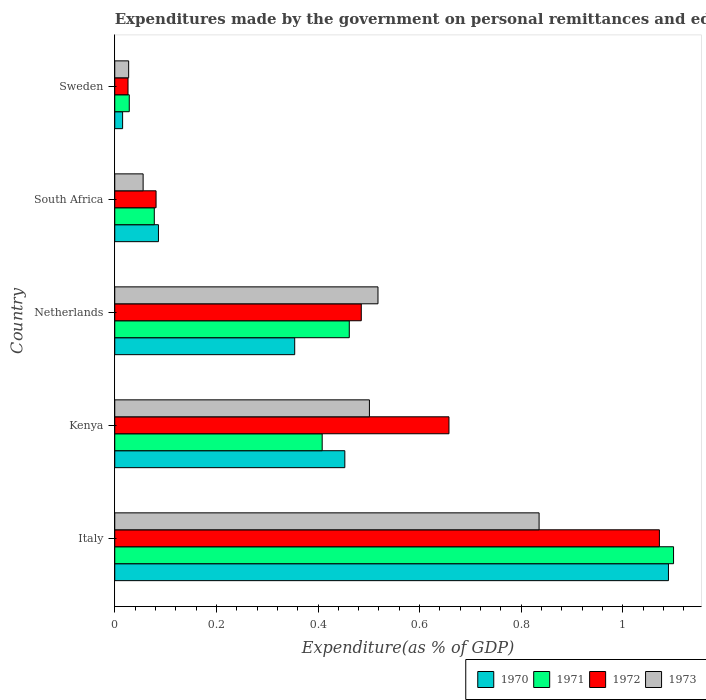How many different coloured bars are there?
Offer a terse response. 4. Are the number of bars per tick equal to the number of legend labels?
Provide a succinct answer. Yes. In how many cases, is the number of bars for a given country not equal to the number of legend labels?
Your answer should be very brief. 0. What is the expenditures made by the government on personal remittances and education in 1971 in South Africa?
Offer a terse response. 0.08. Across all countries, what is the maximum expenditures made by the government on personal remittances and education in 1970?
Offer a terse response. 1.09. Across all countries, what is the minimum expenditures made by the government on personal remittances and education in 1972?
Your response must be concise. 0.03. In which country was the expenditures made by the government on personal remittances and education in 1972 maximum?
Your response must be concise. Italy. In which country was the expenditures made by the government on personal remittances and education in 1970 minimum?
Keep it short and to the point. Sweden. What is the total expenditures made by the government on personal remittances and education in 1972 in the graph?
Offer a very short reply. 2.32. What is the difference between the expenditures made by the government on personal remittances and education in 1970 in Kenya and that in Sweden?
Offer a terse response. 0.44. What is the difference between the expenditures made by the government on personal remittances and education in 1971 in Kenya and the expenditures made by the government on personal remittances and education in 1972 in Netherlands?
Your answer should be compact. -0.08. What is the average expenditures made by the government on personal remittances and education in 1971 per country?
Provide a short and direct response. 0.42. What is the difference between the expenditures made by the government on personal remittances and education in 1972 and expenditures made by the government on personal remittances and education in 1973 in Italy?
Your response must be concise. 0.24. In how many countries, is the expenditures made by the government on personal remittances and education in 1972 greater than 0.56 %?
Offer a very short reply. 2. What is the ratio of the expenditures made by the government on personal remittances and education in 1971 in Kenya to that in Sweden?
Give a very brief answer. 14.29. Is the difference between the expenditures made by the government on personal remittances and education in 1972 in South Africa and Sweden greater than the difference between the expenditures made by the government on personal remittances and education in 1973 in South Africa and Sweden?
Offer a very short reply. Yes. What is the difference between the highest and the second highest expenditures made by the government on personal remittances and education in 1972?
Offer a very short reply. 0.41. What is the difference between the highest and the lowest expenditures made by the government on personal remittances and education in 1972?
Provide a short and direct response. 1.05. What does the 4th bar from the top in Italy represents?
Keep it short and to the point. 1970. Is it the case that in every country, the sum of the expenditures made by the government on personal remittances and education in 1971 and expenditures made by the government on personal remittances and education in 1973 is greater than the expenditures made by the government on personal remittances and education in 1972?
Your answer should be compact. Yes. Are all the bars in the graph horizontal?
Provide a short and direct response. Yes. Where does the legend appear in the graph?
Give a very brief answer. Bottom right. How are the legend labels stacked?
Your response must be concise. Horizontal. What is the title of the graph?
Give a very brief answer. Expenditures made by the government on personal remittances and education. Does "1975" appear as one of the legend labels in the graph?
Your answer should be compact. No. What is the label or title of the X-axis?
Your answer should be very brief. Expenditure(as % of GDP). What is the Expenditure(as % of GDP) in 1970 in Italy?
Give a very brief answer. 1.09. What is the Expenditure(as % of GDP) of 1971 in Italy?
Ensure brevity in your answer.  1.1. What is the Expenditure(as % of GDP) in 1972 in Italy?
Offer a very short reply. 1.07. What is the Expenditure(as % of GDP) in 1973 in Italy?
Offer a terse response. 0.84. What is the Expenditure(as % of GDP) of 1970 in Kenya?
Your answer should be compact. 0.45. What is the Expenditure(as % of GDP) in 1971 in Kenya?
Your response must be concise. 0.41. What is the Expenditure(as % of GDP) of 1972 in Kenya?
Offer a very short reply. 0.66. What is the Expenditure(as % of GDP) in 1973 in Kenya?
Your answer should be very brief. 0.5. What is the Expenditure(as % of GDP) in 1970 in Netherlands?
Your answer should be compact. 0.35. What is the Expenditure(as % of GDP) of 1971 in Netherlands?
Provide a succinct answer. 0.46. What is the Expenditure(as % of GDP) in 1972 in Netherlands?
Ensure brevity in your answer.  0.49. What is the Expenditure(as % of GDP) in 1973 in Netherlands?
Offer a terse response. 0.52. What is the Expenditure(as % of GDP) in 1970 in South Africa?
Give a very brief answer. 0.09. What is the Expenditure(as % of GDP) in 1971 in South Africa?
Your answer should be very brief. 0.08. What is the Expenditure(as % of GDP) of 1972 in South Africa?
Make the answer very short. 0.08. What is the Expenditure(as % of GDP) of 1973 in South Africa?
Offer a terse response. 0.06. What is the Expenditure(as % of GDP) of 1970 in Sweden?
Ensure brevity in your answer.  0.02. What is the Expenditure(as % of GDP) of 1971 in Sweden?
Provide a succinct answer. 0.03. What is the Expenditure(as % of GDP) in 1972 in Sweden?
Ensure brevity in your answer.  0.03. What is the Expenditure(as % of GDP) of 1973 in Sweden?
Provide a succinct answer. 0.03. Across all countries, what is the maximum Expenditure(as % of GDP) of 1970?
Your answer should be very brief. 1.09. Across all countries, what is the maximum Expenditure(as % of GDP) of 1971?
Offer a terse response. 1.1. Across all countries, what is the maximum Expenditure(as % of GDP) in 1972?
Give a very brief answer. 1.07. Across all countries, what is the maximum Expenditure(as % of GDP) in 1973?
Provide a short and direct response. 0.84. Across all countries, what is the minimum Expenditure(as % of GDP) in 1970?
Offer a terse response. 0.02. Across all countries, what is the minimum Expenditure(as % of GDP) in 1971?
Ensure brevity in your answer.  0.03. Across all countries, what is the minimum Expenditure(as % of GDP) in 1972?
Keep it short and to the point. 0.03. Across all countries, what is the minimum Expenditure(as % of GDP) of 1973?
Your answer should be very brief. 0.03. What is the total Expenditure(as % of GDP) in 1970 in the graph?
Ensure brevity in your answer.  2. What is the total Expenditure(as % of GDP) of 1971 in the graph?
Your answer should be very brief. 2.08. What is the total Expenditure(as % of GDP) of 1972 in the graph?
Offer a very short reply. 2.32. What is the total Expenditure(as % of GDP) in 1973 in the graph?
Provide a succinct answer. 1.94. What is the difference between the Expenditure(as % of GDP) of 1970 in Italy and that in Kenya?
Provide a short and direct response. 0.64. What is the difference between the Expenditure(as % of GDP) of 1971 in Italy and that in Kenya?
Your response must be concise. 0.69. What is the difference between the Expenditure(as % of GDP) in 1972 in Italy and that in Kenya?
Offer a very short reply. 0.41. What is the difference between the Expenditure(as % of GDP) in 1973 in Italy and that in Kenya?
Your answer should be compact. 0.33. What is the difference between the Expenditure(as % of GDP) in 1970 in Italy and that in Netherlands?
Your answer should be very brief. 0.74. What is the difference between the Expenditure(as % of GDP) of 1971 in Italy and that in Netherlands?
Your answer should be very brief. 0.64. What is the difference between the Expenditure(as % of GDP) in 1972 in Italy and that in Netherlands?
Offer a terse response. 0.59. What is the difference between the Expenditure(as % of GDP) in 1973 in Italy and that in Netherlands?
Give a very brief answer. 0.32. What is the difference between the Expenditure(as % of GDP) of 1970 in Italy and that in South Africa?
Ensure brevity in your answer.  1. What is the difference between the Expenditure(as % of GDP) in 1971 in Italy and that in South Africa?
Provide a succinct answer. 1.02. What is the difference between the Expenditure(as % of GDP) of 1972 in Italy and that in South Africa?
Offer a very short reply. 0.99. What is the difference between the Expenditure(as % of GDP) of 1973 in Italy and that in South Africa?
Keep it short and to the point. 0.78. What is the difference between the Expenditure(as % of GDP) of 1970 in Italy and that in Sweden?
Your answer should be very brief. 1.07. What is the difference between the Expenditure(as % of GDP) of 1971 in Italy and that in Sweden?
Keep it short and to the point. 1.07. What is the difference between the Expenditure(as % of GDP) of 1972 in Italy and that in Sweden?
Keep it short and to the point. 1.05. What is the difference between the Expenditure(as % of GDP) of 1973 in Italy and that in Sweden?
Your answer should be compact. 0.81. What is the difference between the Expenditure(as % of GDP) of 1970 in Kenya and that in Netherlands?
Ensure brevity in your answer.  0.1. What is the difference between the Expenditure(as % of GDP) in 1971 in Kenya and that in Netherlands?
Your answer should be very brief. -0.05. What is the difference between the Expenditure(as % of GDP) of 1972 in Kenya and that in Netherlands?
Offer a terse response. 0.17. What is the difference between the Expenditure(as % of GDP) in 1973 in Kenya and that in Netherlands?
Make the answer very short. -0.02. What is the difference between the Expenditure(as % of GDP) in 1970 in Kenya and that in South Africa?
Your response must be concise. 0.37. What is the difference between the Expenditure(as % of GDP) of 1971 in Kenya and that in South Africa?
Your answer should be very brief. 0.33. What is the difference between the Expenditure(as % of GDP) in 1972 in Kenya and that in South Africa?
Ensure brevity in your answer.  0.58. What is the difference between the Expenditure(as % of GDP) in 1973 in Kenya and that in South Africa?
Ensure brevity in your answer.  0.45. What is the difference between the Expenditure(as % of GDP) of 1970 in Kenya and that in Sweden?
Provide a succinct answer. 0.44. What is the difference between the Expenditure(as % of GDP) of 1971 in Kenya and that in Sweden?
Offer a terse response. 0.38. What is the difference between the Expenditure(as % of GDP) of 1972 in Kenya and that in Sweden?
Keep it short and to the point. 0.63. What is the difference between the Expenditure(as % of GDP) in 1973 in Kenya and that in Sweden?
Provide a short and direct response. 0.47. What is the difference between the Expenditure(as % of GDP) of 1970 in Netherlands and that in South Africa?
Your response must be concise. 0.27. What is the difference between the Expenditure(as % of GDP) of 1971 in Netherlands and that in South Africa?
Provide a succinct answer. 0.38. What is the difference between the Expenditure(as % of GDP) in 1972 in Netherlands and that in South Africa?
Your answer should be compact. 0.4. What is the difference between the Expenditure(as % of GDP) of 1973 in Netherlands and that in South Africa?
Provide a succinct answer. 0.46. What is the difference between the Expenditure(as % of GDP) of 1970 in Netherlands and that in Sweden?
Your answer should be very brief. 0.34. What is the difference between the Expenditure(as % of GDP) in 1971 in Netherlands and that in Sweden?
Your answer should be compact. 0.43. What is the difference between the Expenditure(as % of GDP) in 1972 in Netherlands and that in Sweden?
Offer a terse response. 0.46. What is the difference between the Expenditure(as % of GDP) of 1973 in Netherlands and that in Sweden?
Make the answer very short. 0.49. What is the difference between the Expenditure(as % of GDP) of 1970 in South Africa and that in Sweden?
Offer a very short reply. 0.07. What is the difference between the Expenditure(as % of GDP) in 1971 in South Africa and that in Sweden?
Provide a succinct answer. 0.05. What is the difference between the Expenditure(as % of GDP) in 1972 in South Africa and that in Sweden?
Give a very brief answer. 0.06. What is the difference between the Expenditure(as % of GDP) of 1973 in South Africa and that in Sweden?
Give a very brief answer. 0.03. What is the difference between the Expenditure(as % of GDP) of 1970 in Italy and the Expenditure(as % of GDP) of 1971 in Kenya?
Offer a very short reply. 0.68. What is the difference between the Expenditure(as % of GDP) of 1970 in Italy and the Expenditure(as % of GDP) of 1972 in Kenya?
Keep it short and to the point. 0.43. What is the difference between the Expenditure(as % of GDP) of 1970 in Italy and the Expenditure(as % of GDP) of 1973 in Kenya?
Keep it short and to the point. 0.59. What is the difference between the Expenditure(as % of GDP) in 1971 in Italy and the Expenditure(as % of GDP) in 1972 in Kenya?
Your response must be concise. 0.44. What is the difference between the Expenditure(as % of GDP) of 1971 in Italy and the Expenditure(as % of GDP) of 1973 in Kenya?
Make the answer very short. 0.6. What is the difference between the Expenditure(as % of GDP) in 1972 in Italy and the Expenditure(as % of GDP) in 1973 in Kenya?
Your response must be concise. 0.57. What is the difference between the Expenditure(as % of GDP) in 1970 in Italy and the Expenditure(as % of GDP) in 1971 in Netherlands?
Provide a short and direct response. 0.63. What is the difference between the Expenditure(as % of GDP) in 1970 in Italy and the Expenditure(as % of GDP) in 1972 in Netherlands?
Ensure brevity in your answer.  0.6. What is the difference between the Expenditure(as % of GDP) of 1970 in Italy and the Expenditure(as % of GDP) of 1973 in Netherlands?
Provide a short and direct response. 0.57. What is the difference between the Expenditure(as % of GDP) of 1971 in Italy and the Expenditure(as % of GDP) of 1972 in Netherlands?
Offer a very short reply. 0.61. What is the difference between the Expenditure(as % of GDP) of 1971 in Italy and the Expenditure(as % of GDP) of 1973 in Netherlands?
Keep it short and to the point. 0.58. What is the difference between the Expenditure(as % of GDP) in 1972 in Italy and the Expenditure(as % of GDP) in 1973 in Netherlands?
Ensure brevity in your answer.  0.55. What is the difference between the Expenditure(as % of GDP) in 1970 in Italy and the Expenditure(as % of GDP) in 1971 in South Africa?
Offer a terse response. 1.01. What is the difference between the Expenditure(as % of GDP) in 1970 in Italy and the Expenditure(as % of GDP) in 1972 in South Africa?
Your answer should be very brief. 1.01. What is the difference between the Expenditure(as % of GDP) in 1970 in Italy and the Expenditure(as % of GDP) in 1973 in South Africa?
Your answer should be very brief. 1.03. What is the difference between the Expenditure(as % of GDP) in 1971 in Italy and the Expenditure(as % of GDP) in 1972 in South Africa?
Ensure brevity in your answer.  1.02. What is the difference between the Expenditure(as % of GDP) in 1971 in Italy and the Expenditure(as % of GDP) in 1973 in South Africa?
Your answer should be compact. 1.04. What is the difference between the Expenditure(as % of GDP) in 1972 in Italy and the Expenditure(as % of GDP) in 1973 in South Africa?
Your answer should be very brief. 1.02. What is the difference between the Expenditure(as % of GDP) in 1970 in Italy and the Expenditure(as % of GDP) in 1971 in Sweden?
Give a very brief answer. 1.06. What is the difference between the Expenditure(as % of GDP) in 1970 in Italy and the Expenditure(as % of GDP) in 1972 in Sweden?
Your answer should be compact. 1.06. What is the difference between the Expenditure(as % of GDP) in 1970 in Italy and the Expenditure(as % of GDP) in 1973 in Sweden?
Your answer should be very brief. 1.06. What is the difference between the Expenditure(as % of GDP) of 1971 in Italy and the Expenditure(as % of GDP) of 1972 in Sweden?
Make the answer very short. 1.07. What is the difference between the Expenditure(as % of GDP) in 1971 in Italy and the Expenditure(as % of GDP) in 1973 in Sweden?
Provide a short and direct response. 1.07. What is the difference between the Expenditure(as % of GDP) of 1972 in Italy and the Expenditure(as % of GDP) of 1973 in Sweden?
Offer a terse response. 1.04. What is the difference between the Expenditure(as % of GDP) of 1970 in Kenya and the Expenditure(as % of GDP) of 1971 in Netherlands?
Your answer should be very brief. -0.01. What is the difference between the Expenditure(as % of GDP) in 1970 in Kenya and the Expenditure(as % of GDP) in 1972 in Netherlands?
Your answer should be very brief. -0.03. What is the difference between the Expenditure(as % of GDP) in 1970 in Kenya and the Expenditure(as % of GDP) in 1973 in Netherlands?
Offer a terse response. -0.07. What is the difference between the Expenditure(as % of GDP) of 1971 in Kenya and the Expenditure(as % of GDP) of 1972 in Netherlands?
Your response must be concise. -0.08. What is the difference between the Expenditure(as % of GDP) in 1971 in Kenya and the Expenditure(as % of GDP) in 1973 in Netherlands?
Your answer should be compact. -0.11. What is the difference between the Expenditure(as % of GDP) of 1972 in Kenya and the Expenditure(as % of GDP) of 1973 in Netherlands?
Your response must be concise. 0.14. What is the difference between the Expenditure(as % of GDP) of 1970 in Kenya and the Expenditure(as % of GDP) of 1972 in South Africa?
Offer a terse response. 0.37. What is the difference between the Expenditure(as % of GDP) of 1970 in Kenya and the Expenditure(as % of GDP) of 1973 in South Africa?
Give a very brief answer. 0.4. What is the difference between the Expenditure(as % of GDP) of 1971 in Kenya and the Expenditure(as % of GDP) of 1972 in South Africa?
Your response must be concise. 0.33. What is the difference between the Expenditure(as % of GDP) in 1971 in Kenya and the Expenditure(as % of GDP) in 1973 in South Africa?
Give a very brief answer. 0.35. What is the difference between the Expenditure(as % of GDP) of 1972 in Kenya and the Expenditure(as % of GDP) of 1973 in South Africa?
Offer a very short reply. 0.6. What is the difference between the Expenditure(as % of GDP) of 1970 in Kenya and the Expenditure(as % of GDP) of 1971 in Sweden?
Keep it short and to the point. 0.42. What is the difference between the Expenditure(as % of GDP) in 1970 in Kenya and the Expenditure(as % of GDP) in 1972 in Sweden?
Make the answer very short. 0.43. What is the difference between the Expenditure(as % of GDP) in 1970 in Kenya and the Expenditure(as % of GDP) in 1973 in Sweden?
Ensure brevity in your answer.  0.43. What is the difference between the Expenditure(as % of GDP) of 1971 in Kenya and the Expenditure(as % of GDP) of 1972 in Sweden?
Give a very brief answer. 0.38. What is the difference between the Expenditure(as % of GDP) in 1971 in Kenya and the Expenditure(as % of GDP) in 1973 in Sweden?
Offer a very short reply. 0.38. What is the difference between the Expenditure(as % of GDP) in 1972 in Kenya and the Expenditure(as % of GDP) in 1973 in Sweden?
Make the answer very short. 0.63. What is the difference between the Expenditure(as % of GDP) in 1970 in Netherlands and the Expenditure(as % of GDP) in 1971 in South Africa?
Your answer should be compact. 0.28. What is the difference between the Expenditure(as % of GDP) in 1970 in Netherlands and the Expenditure(as % of GDP) in 1972 in South Africa?
Ensure brevity in your answer.  0.27. What is the difference between the Expenditure(as % of GDP) of 1970 in Netherlands and the Expenditure(as % of GDP) of 1973 in South Africa?
Your response must be concise. 0.3. What is the difference between the Expenditure(as % of GDP) of 1971 in Netherlands and the Expenditure(as % of GDP) of 1972 in South Africa?
Make the answer very short. 0.38. What is the difference between the Expenditure(as % of GDP) of 1971 in Netherlands and the Expenditure(as % of GDP) of 1973 in South Africa?
Your response must be concise. 0.41. What is the difference between the Expenditure(as % of GDP) of 1972 in Netherlands and the Expenditure(as % of GDP) of 1973 in South Africa?
Offer a very short reply. 0.43. What is the difference between the Expenditure(as % of GDP) of 1970 in Netherlands and the Expenditure(as % of GDP) of 1971 in Sweden?
Keep it short and to the point. 0.33. What is the difference between the Expenditure(as % of GDP) of 1970 in Netherlands and the Expenditure(as % of GDP) of 1972 in Sweden?
Your response must be concise. 0.33. What is the difference between the Expenditure(as % of GDP) in 1970 in Netherlands and the Expenditure(as % of GDP) in 1973 in Sweden?
Provide a short and direct response. 0.33. What is the difference between the Expenditure(as % of GDP) in 1971 in Netherlands and the Expenditure(as % of GDP) in 1972 in Sweden?
Provide a short and direct response. 0.44. What is the difference between the Expenditure(as % of GDP) in 1971 in Netherlands and the Expenditure(as % of GDP) in 1973 in Sweden?
Keep it short and to the point. 0.43. What is the difference between the Expenditure(as % of GDP) in 1972 in Netherlands and the Expenditure(as % of GDP) in 1973 in Sweden?
Your response must be concise. 0.46. What is the difference between the Expenditure(as % of GDP) of 1970 in South Africa and the Expenditure(as % of GDP) of 1971 in Sweden?
Provide a short and direct response. 0.06. What is the difference between the Expenditure(as % of GDP) in 1970 in South Africa and the Expenditure(as % of GDP) in 1972 in Sweden?
Provide a short and direct response. 0.06. What is the difference between the Expenditure(as % of GDP) of 1970 in South Africa and the Expenditure(as % of GDP) of 1973 in Sweden?
Your answer should be compact. 0.06. What is the difference between the Expenditure(as % of GDP) in 1971 in South Africa and the Expenditure(as % of GDP) in 1972 in Sweden?
Your answer should be compact. 0.05. What is the difference between the Expenditure(as % of GDP) in 1971 in South Africa and the Expenditure(as % of GDP) in 1973 in Sweden?
Offer a very short reply. 0.05. What is the difference between the Expenditure(as % of GDP) of 1972 in South Africa and the Expenditure(as % of GDP) of 1973 in Sweden?
Your response must be concise. 0.05. What is the average Expenditure(as % of GDP) in 1970 per country?
Offer a terse response. 0.4. What is the average Expenditure(as % of GDP) of 1971 per country?
Provide a succinct answer. 0.42. What is the average Expenditure(as % of GDP) of 1972 per country?
Give a very brief answer. 0.46. What is the average Expenditure(as % of GDP) of 1973 per country?
Provide a short and direct response. 0.39. What is the difference between the Expenditure(as % of GDP) in 1970 and Expenditure(as % of GDP) in 1971 in Italy?
Keep it short and to the point. -0.01. What is the difference between the Expenditure(as % of GDP) in 1970 and Expenditure(as % of GDP) in 1972 in Italy?
Offer a terse response. 0.02. What is the difference between the Expenditure(as % of GDP) of 1970 and Expenditure(as % of GDP) of 1973 in Italy?
Offer a terse response. 0.25. What is the difference between the Expenditure(as % of GDP) in 1971 and Expenditure(as % of GDP) in 1972 in Italy?
Offer a terse response. 0.03. What is the difference between the Expenditure(as % of GDP) of 1971 and Expenditure(as % of GDP) of 1973 in Italy?
Offer a terse response. 0.26. What is the difference between the Expenditure(as % of GDP) of 1972 and Expenditure(as % of GDP) of 1973 in Italy?
Offer a very short reply. 0.24. What is the difference between the Expenditure(as % of GDP) of 1970 and Expenditure(as % of GDP) of 1971 in Kenya?
Offer a terse response. 0.04. What is the difference between the Expenditure(as % of GDP) of 1970 and Expenditure(as % of GDP) of 1972 in Kenya?
Keep it short and to the point. -0.2. What is the difference between the Expenditure(as % of GDP) of 1970 and Expenditure(as % of GDP) of 1973 in Kenya?
Provide a short and direct response. -0.05. What is the difference between the Expenditure(as % of GDP) of 1971 and Expenditure(as % of GDP) of 1972 in Kenya?
Offer a terse response. -0.25. What is the difference between the Expenditure(as % of GDP) in 1971 and Expenditure(as % of GDP) in 1973 in Kenya?
Ensure brevity in your answer.  -0.09. What is the difference between the Expenditure(as % of GDP) in 1972 and Expenditure(as % of GDP) in 1973 in Kenya?
Keep it short and to the point. 0.16. What is the difference between the Expenditure(as % of GDP) of 1970 and Expenditure(as % of GDP) of 1971 in Netherlands?
Your answer should be very brief. -0.11. What is the difference between the Expenditure(as % of GDP) of 1970 and Expenditure(as % of GDP) of 1972 in Netherlands?
Ensure brevity in your answer.  -0.13. What is the difference between the Expenditure(as % of GDP) in 1970 and Expenditure(as % of GDP) in 1973 in Netherlands?
Your answer should be very brief. -0.16. What is the difference between the Expenditure(as % of GDP) of 1971 and Expenditure(as % of GDP) of 1972 in Netherlands?
Ensure brevity in your answer.  -0.02. What is the difference between the Expenditure(as % of GDP) in 1971 and Expenditure(as % of GDP) in 1973 in Netherlands?
Your answer should be compact. -0.06. What is the difference between the Expenditure(as % of GDP) of 1972 and Expenditure(as % of GDP) of 1973 in Netherlands?
Make the answer very short. -0.03. What is the difference between the Expenditure(as % of GDP) of 1970 and Expenditure(as % of GDP) of 1971 in South Africa?
Offer a very short reply. 0.01. What is the difference between the Expenditure(as % of GDP) of 1970 and Expenditure(as % of GDP) of 1972 in South Africa?
Keep it short and to the point. 0. What is the difference between the Expenditure(as % of GDP) in 1970 and Expenditure(as % of GDP) in 1973 in South Africa?
Offer a terse response. 0.03. What is the difference between the Expenditure(as % of GDP) of 1971 and Expenditure(as % of GDP) of 1972 in South Africa?
Give a very brief answer. -0. What is the difference between the Expenditure(as % of GDP) of 1971 and Expenditure(as % of GDP) of 1973 in South Africa?
Provide a short and direct response. 0.02. What is the difference between the Expenditure(as % of GDP) in 1972 and Expenditure(as % of GDP) in 1973 in South Africa?
Your answer should be compact. 0.03. What is the difference between the Expenditure(as % of GDP) in 1970 and Expenditure(as % of GDP) in 1971 in Sweden?
Make the answer very short. -0.01. What is the difference between the Expenditure(as % of GDP) in 1970 and Expenditure(as % of GDP) in 1972 in Sweden?
Give a very brief answer. -0.01. What is the difference between the Expenditure(as % of GDP) in 1970 and Expenditure(as % of GDP) in 1973 in Sweden?
Your answer should be very brief. -0.01. What is the difference between the Expenditure(as % of GDP) in 1971 and Expenditure(as % of GDP) in 1972 in Sweden?
Provide a short and direct response. 0. What is the difference between the Expenditure(as % of GDP) in 1971 and Expenditure(as % of GDP) in 1973 in Sweden?
Your answer should be very brief. 0. What is the difference between the Expenditure(as % of GDP) in 1972 and Expenditure(as % of GDP) in 1973 in Sweden?
Your response must be concise. -0. What is the ratio of the Expenditure(as % of GDP) of 1970 in Italy to that in Kenya?
Your answer should be compact. 2.41. What is the ratio of the Expenditure(as % of GDP) in 1971 in Italy to that in Kenya?
Provide a succinct answer. 2.69. What is the ratio of the Expenditure(as % of GDP) of 1972 in Italy to that in Kenya?
Make the answer very short. 1.63. What is the ratio of the Expenditure(as % of GDP) of 1973 in Italy to that in Kenya?
Your answer should be very brief. 1.67. What is the ratio of the Expenditure(as % of GDP) of 1970 in Italy to that in Netherlands?
Provide a short and direct response. 3.08. What is the ratio of the Expenditure(as % of GDP) in 1971 in Italy to that in Netherlands?
Provide a short and direct response. 2.38. What is the ratio of the Expenditure(as % of GDP) in 1972 in Italy to that in Netherlands?
Provide a short and direct response. 2.21. What is the ratio of the Expenditure(as % of GDP) of 1973 in Italy to that in Netherlands?
Provide a succinct answer. 1.61. What is the ratio of the Expenditure(as % of GDP) in 1970 in Italy to that in South Africa?
Provide a succinct answer. 12.67. What is the ratio of the Expenditure(as % of GDP) in 1971 in Italy to that in South Africa?
Your response must be concise. 14.13. What is the ratio of the Expenditure(as % of GDP) in 1972 in Italy to that in South Africa?
Make the answer very short. 13.18. What is the ratio of the Expenditure(as % of GDP) in 1973 in Italy to that in South Africa?
Offer a very short reply. 14.96. What is the ratio of the Expenditure(as % of GDP) in 1970 in Italy to that in Sweden?
Your response must be concise. 70.57. What is the ratio of the Expenditure(as % of GDP) in 1971 in Italy to that in Sweden?
Make the answer very short. 38.5. What is the ratio of the Expenditure(as % of GDP) in 1972 in Italy to that in Sweden?
Your response must be concise. 41.06. What is the ratio of the Expenditure(as % of GDP) of 1973 in Italy to that in Sweden?
Keep it short and to the point. 30.51. What is the ratio of the Expenditure(as % of GDP) of 1970 in Kenya to that in Netherlands?
Ensure brevity in your answer.  1.28. What is the ratio of the Expenditure(as % of GDP) of 1971 in Kenya to that in Netherlands?
Offer a terse response. 0.88. What is the ratio of the Expenditure(as % of GDP) in 1972 in Kenya to that in Netherlands?
Ensure brevity in your answer.  1.36. What is the ratio of the Expenditure(as % of GDP) in 1973 in Kenya to that in Netherlands?
Offer a terse response. 0.97. What is the ratio of the Expenditure(as % of GDP) of 1970 in Kenya to that in South Africa?
Provide a short and direct response. 5.26. What is the ratio of the Expenditure(as % of GDP) of 1971 in Kenya to that in South Africa?
Offer a very short reply. 5.25. What is the ratio of the Expenditure(as % of GDP) in 1972 in Kenya to that in South Africa?
Provide a succinct answer. 8.09. What is the ratio of the Expenditure(as % of GDP) in 1973 in Kenya to that in South Africa?
Provide a short and direct response. 8.98. What is the ratio of the Expenditure(as % of GDP) of 1970 in Kenya to that in Sweden?
Offer a terse response. 29.32. What is the ratio of the Expenditure(as % of GDP) in 1971 in Kenya to that in Sweden?
Give a very brief answer. 14.29. What is the ratio of the Expenditure(as % of GDP) of 1972 in Kenya to that in Sweden?
Ensure brevity in your answer.  25.2. What is the ratio of the Expenditure(as % of GDP) in 1973 in Kenya to that in Sweden?
Your answer should be compact. 18.31. What is the ratio of the Expenditure(as % of GDP) of 1970 in Netherlands to that in South Africa?
Provide a succinct answer. 4.12. What is the ratio of the Expenditure(as % of GDP) in 1971 in Netherlands to that in South Africa?
Your answer should be compact. 5.93. What is the ratio of the Expenditure(as % of GDP) of 1972 in Netherlands to that in South Africa?
Provide a short and direct response. 5.97. What is the ratio of the Expenditure(as % of GDP) of 1973 in Netherlands to that in South Africa?
Give a very brief answer. 9.28. What is the ratio of the Expenditure(as % of GDP) of 1970 in Netherlands to that in Sweden?
Provide a short and direct response. 22.93. What is the ratio of the Expenditure(as % of GDP) of 1971 in Netherlands to that in Sweden?
Offer a terse response. 16.16. What is the ratio of the Expenditure(as % of GDP) of 1972 in Netherlands to that in Sweden?
Your answer should be compact. 18.59. What is the ratio of the Expenditure(as % of GDP) of 1973 in Netherlands to that in Sweden?
Give a very brief answer. 18.93. What is the ratio of the Expenditure(as % of GDP) in 1970 in South Africa to that in Sweden?
Your response must be concise. 5.57. What is the ratio of the Expenditure(as % of GDP) of 1971 in South Africa to that in Sweden?
Offer a very short reply. 2.72. What is the ratio of the Expenditure(as % of GDP) in 1972 in South Africa to that in Sweden?
Give a very brief answer. 3.11. What is the ratio of the Expenditure(as % of GDP) in 1973 in South Africa to that in Sweden?
Your response must be concise. 2.04. What is the difference between the highest and the second highest Expenditure(as % of GDP) in 1970?
Give a very brief answer. 0.64. What is the difference between the highest and the second highest Expenditure(as % of GDP) in 1971?
Offer a terse response. 0.64. What is the difference between the highest and the second highest Expenditure(as % of GDP) in 1972?
Your answer should be compact. 0.41. What is the difference between the highest and the second highest Expenditure(as % of GDP) in 1973?
Your answer should be compact. 0.32. What is the difference between the highest and the lowest Expenditure(as % of GDP) of 1970?
Provide a short and direct response. 1.07. What is the difference between the highest and the lowest Expenditure(as % of GDP) in 1971?
Your answer should be very brief. 1.07. What is the difference between the highest and the lowest Expenditure(as % of GDP) in 1972?
Keep it short and to the point. 1.05. What is the difference between the highest and the lowest Expenditure(as % of GDP) of 1973?
Provide a short and direct response. 0.81. 